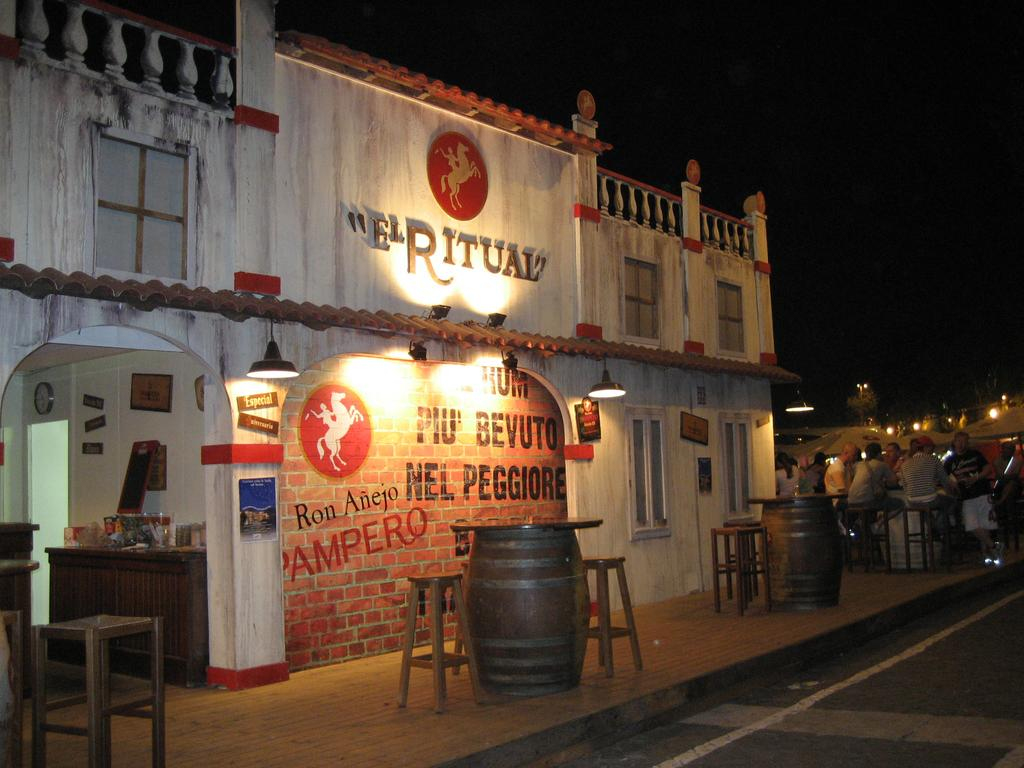<image>
Give a short and clear explanation of the subsequent image. White cement store front with "El Ritual" in gold lettering. 